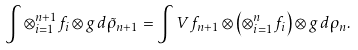<formula> <loc_0><loc_0><loc_500><loc_500>\int \otimes _ { i = 1 } ^ { n + 1 } f _ { i } \otimes g \, d \tilde { \rho } _ { n + 1 } = \int V f _ { n + 1 } \otimes \left ( \otimes _ { i = 1 } ^ { n } f _ { i } \right ) \otimes g \, d \rho _ { n } .</formula> 